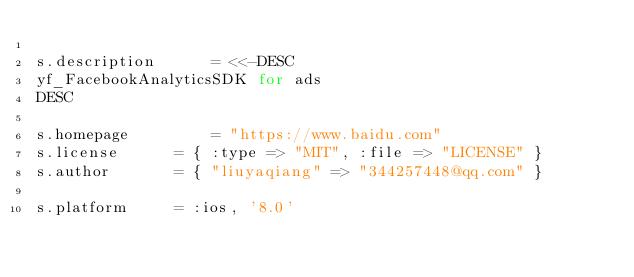<code> <loc_0><loc_0><loc_500><loc_500><_Ruby_>
s.description      = <<-DESC
yf_FacebookAnalyticsSDK for ads
DESC

s.homepage         = "https://www.baidu.com"
s.license      = { :type => "MIT", :file => "LICENSE" }
s.author       = { "liuyaqiang" => "344257448@qq.com" }

s.platform     = :ios, '8.0'</code> 